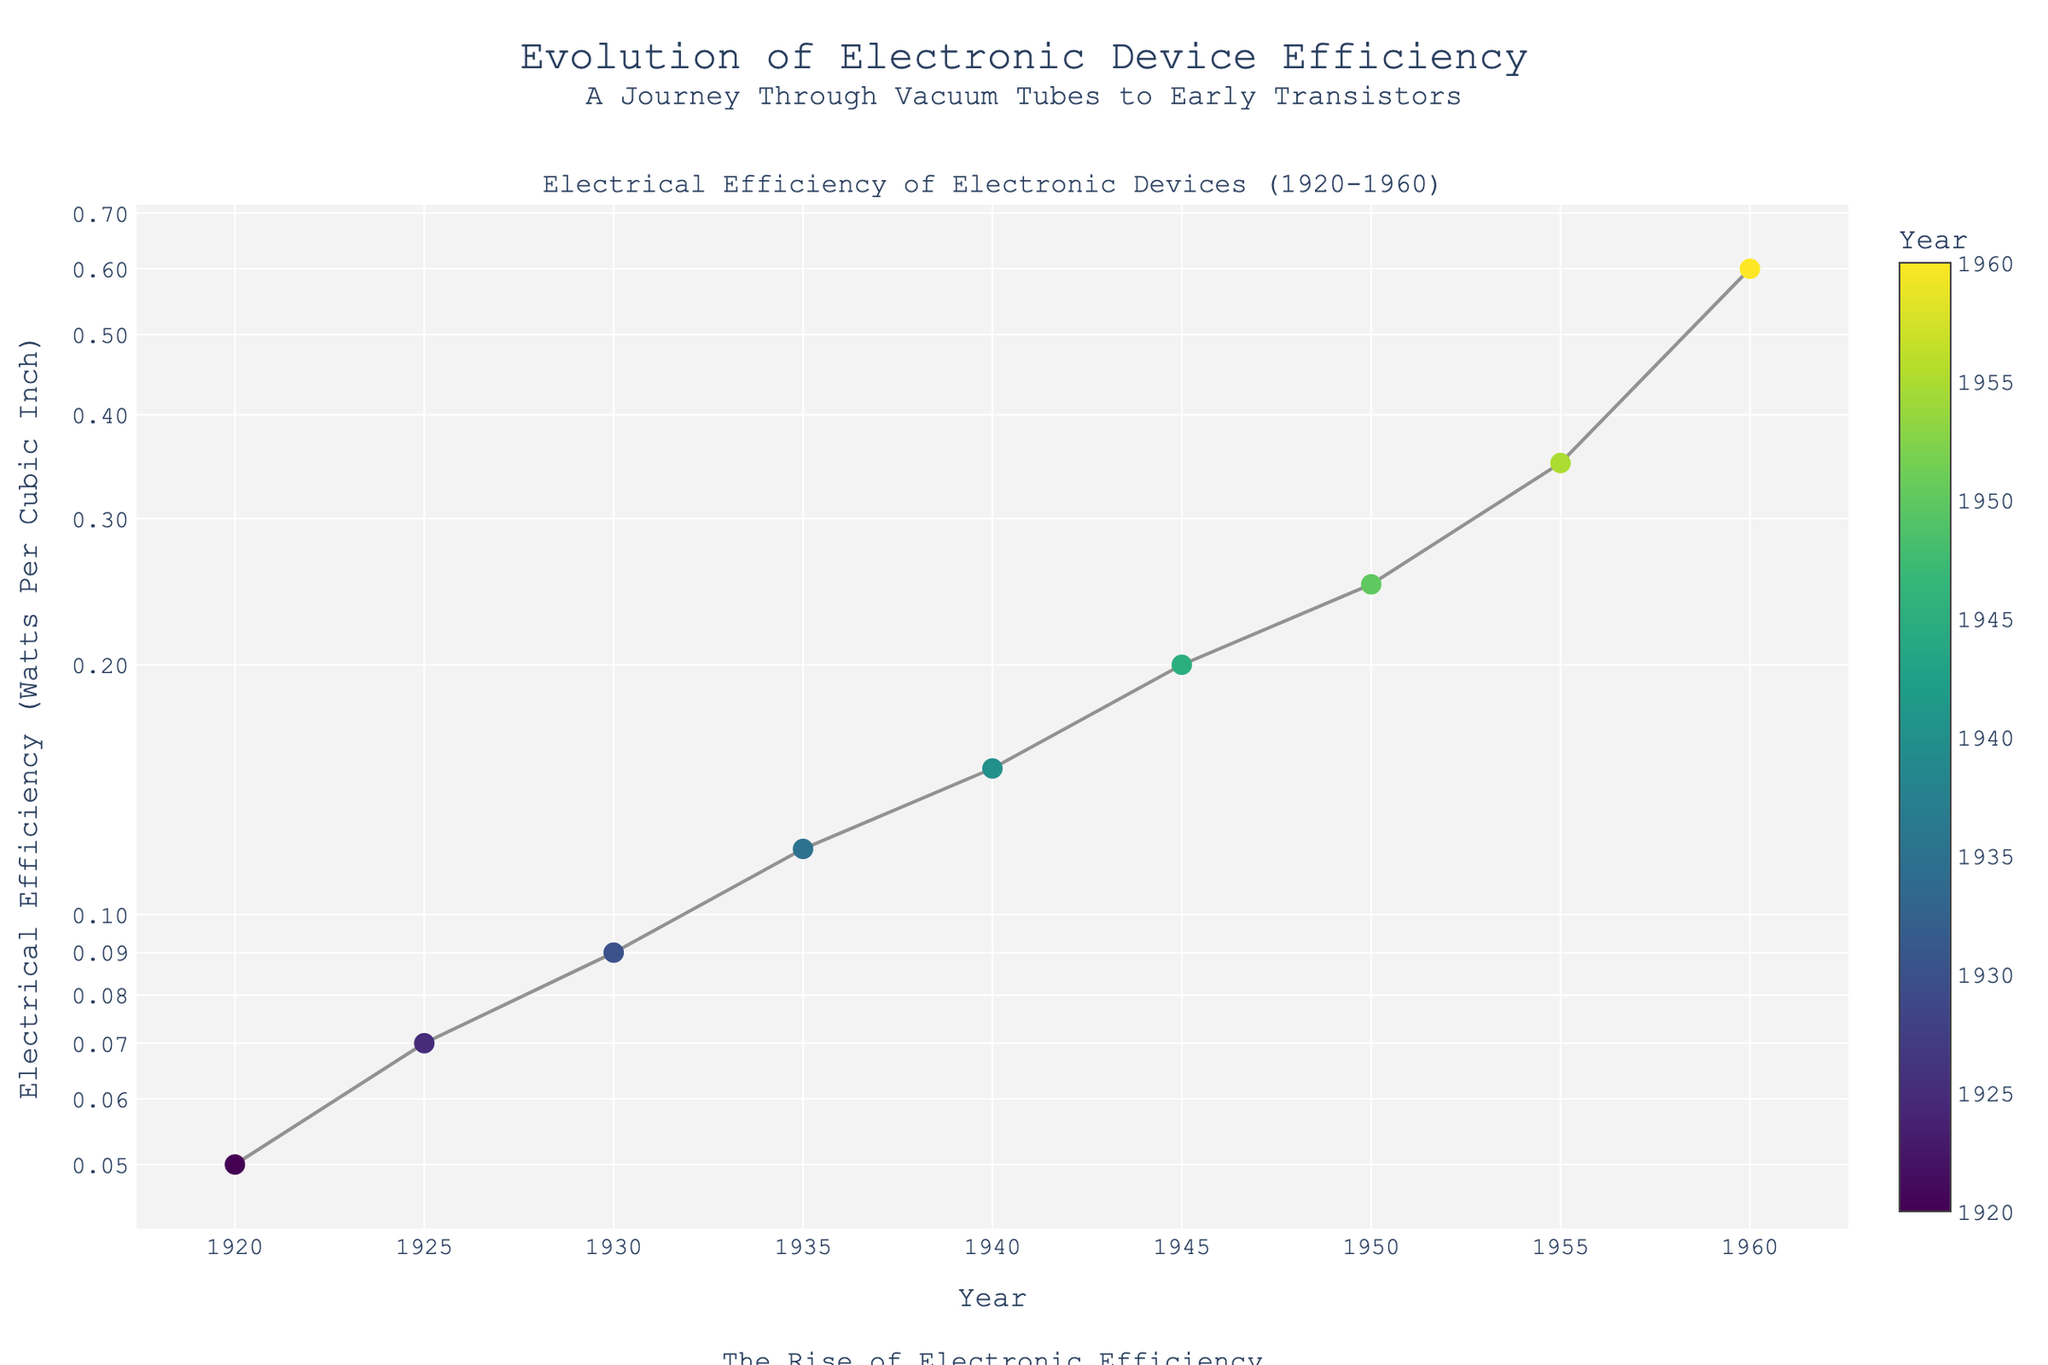What is the range of years covered by this plot? The x-axis covers the years, and the data points range from the earliest year to the latest year shown in the plot. The first data point is from 1920, and the last data point is from 1960.
Answer: 1920 to 1960 How does the electrical efficiency trend over time? Observe the markers and the connecting line in the plot. The electrical efficiency consistently increases over time, depicted by a rising line from left to right.
Answer: Increases Which device shows the highest electrical efficiency in the plot? Look for the data point at the highest position on the log scale y-axis. The highest value is near 0.60 watts per cubic inch around the year 1960.
Answer: Transistor Radio Sony TR-63 Which two consecutive years show the largest increase in electrical efficiency? Compare the gaps between each consecutive data point along the y-axis. The largest gap appears just before the year 1960, between 1955 and 1960.
Answer: 1955 to 1960 What is the approximate electrical efficiency of the device in 1940? Locate the data point corresponding to the year 1940 on the x-axis and read its y-axis value. It is approximately 0.15 watts per cubic inch.
Answer: 0.15 W/in³ What is the difference in efficiency between the devices in 1920 and 1960? Identify the efficiencies for 1920 and 1960 from the plot (0.05 and 0.60, respectively) and subtract them. This yields the difference in efficiency.
Answer: 0.55 W/in³ How does the data distribution appear in a log scale compared to a linear scale? Note that in a log scale, equal vertical distances represent multiplicative changes. This causes smaller increases in the earlier years and larger increases in later years to be more visually proportional.
Answer: More proportionate increases What is the median electrical efficiency over the years presented? Arrange the efficiencies in ascending order and find the middle value. The list is: 0.05, 0.07, 0.09, 0.12, 0.15, 0.20, 0.25, 0.35, 0.60. The median value is the fifth one in this list: 0.15.
Answer: 0.15 W/in³ How many devices are represented in the figure? Count the number of distinct data points on the plot. There are data points for each device, and there are nine devices altogether in the range from 1920 to 1960.
Answer: 9 devices Which color represents the oldest devices in the plot? Examine the colorbar and the corresponding colors for earlier years around 1920. The colors for the oldest devices are at the low end of the colorscale, likely dark purple.
Answer: Dark purple 